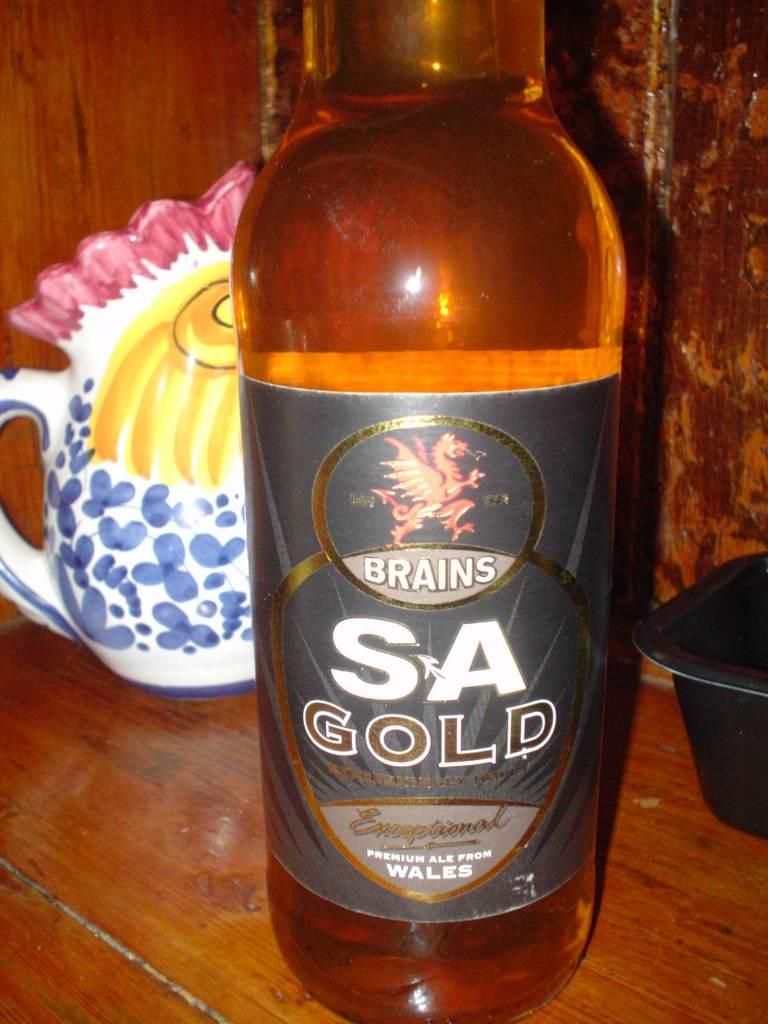Where is this drink from?
Provide a succinct answer. Wales. 